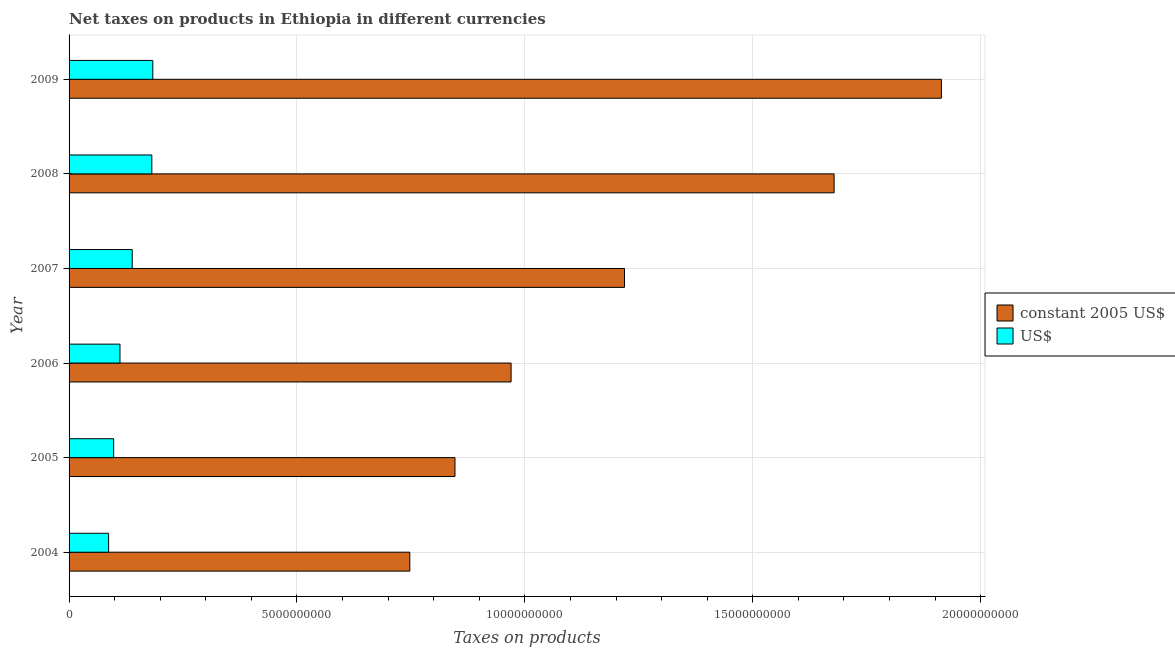How many different coloured bars are there?
Your answer should be compact. 2. How many groups of bars are there?
Your response must be concise. 6. How many bars are there on the 6th tick from the top?
Provide a succinct answer. 2. What is the label of the 2nd group of bars from the top?
Your answer should be compact. 2008. What is the net taxes in us$ in 2005?
Provide a short and direct response. 9.79e+08. Across all years, what is the maximum net taxes in us$?
Your answer should be compact. 1.84e+09. Across all years, what is the minimum net taxes in us$?
Your answer should be compact. 8.67e+08. What is the total net taxes in constant 2005 us$ in the graph?
Offer a very short reply. 7.38e+1. What is the difference between the net taxes in constant 2005 us$ in 2005 and that in 2007?
Keep it short and to the point. -3.72e+09. What is the difference between the net taxes in us$ in 2006 and the net taxes in constant 2005 us$ in 2007?
Ensure brevity in your answer.  -1.11e+1. What is the average net taxes in us$ per year?
Provide a succinct answer. 1.33e+09. In the year 2007, what is the difference between the net taxes in us$ and net taxes in constant 2005 us$?
Offer a very short reply. -1.08e+1. Is the difference between the net taxes in constant 2005 us$ in 2006 and 2007 greater than the difference between the net taxes in us$ in 2006 and 2007?
Make the answer very short. No. What is the difference between the highest and the second highest net taxes in us$?
Give a very brief answer. 2.12e+07. What is the difference between the highest and the lowest net taxes in us$?
Keep it short and to the point. 9.70e+08. In how many years, is the net taxes in constant 2005 us$ greater than the average net taxes in constant 2005 us$ taken over all years?
Provide a short and direct response. 2. What does the 1st bar from the top in 2009 represents?
Your response must be concise. US$. What does the 2nd bar from the bottom in 2006 represents?
Keep it short and to the point. US$. How many bars are there?
Provide a succinct answer. 12. What is the difference between two consecutive major ticks on the X-axis?
Keep it short and to the point. 5.00e+09. Are the values on the major ticks of X-axis written in scientific E-notation?
Your answer should be very brief. No. Does the graph contain grids?
Your response must be concise. Yes. What is the title of the graph?
Offer a terse response. Net taxes on products in Ethiopia in different currencies. What is the label or title of the X-axis?
Your answer should be very brief. Taxes on products. What is the label or title of the Y-axis?
Provide a succinct answer. Year. What is the Taxes on products in constant 2005 US$ in 2004?
Make the answer very short. 7.48e+09. What is the Taxes on products of US$ in 2004?
Give a very brief answer. 8.67e+08. What is the Taxes on products in constant 2005 US$ in 2005?
Your answer should be compact. 8.47e+09. What is the Taxes on products of US$ in 2005?
Your answer should be very brief. 9.79e+08. What is the Taxes on products of constant 2005 US$ in 2006?
Ensure brevity in your answer.  9.70e+09. What is the Taxes on products in US$ in 2006?
Your answer should be compact. 1.12e+09. What is the Taxes on products of constant 2005 US$ in 2007?
Provide a succinct answer. 1.22e+1. What is the Taxes on products in US$ in 2007?
Provide a short and direct response. 1.39e+09. What is the Taxes on products in constant 2005 US$ in 2008?
Your answer should be compact. 1.68e+1. What is the Taxes on products in US$ in 2008?
Make the answer very short. 1.82e+09. What is the Taxes on products of constant 2005 US$ in 2009?
Offer a terse response. 1.91e+1. What is the Taxes on products of US$ in 2009?
Provide a succinct answer. 1.84e+09. Across all years, what is the maximum Taxes on products in constant 2005 US$?
Provide a short and direct response. 1.91e+1. Across all years, what is the maximum Taxes on products of US$?
Keep it short and to the point. 1.84e+09. Across all years, what is the minimum Taxes on products in constant 2005 US$?
Offer a very short reply. 7.48e+09. Across all years, what is the minimum Taxes on products of US$?
Make the answer very short. 8.67e+08. What is the total Taxes on products in constant 2005 US$ in the graph?
Make the answer very short. 7.38e+1. What is the total Taxes on products of US$ in the graph?
Your answer should be compact. 8.00e+09. What is the difference between the Taxes on products of constant 2005 US$ in 2004 and that in 2005?
Give a very brief answer. -9.91e+08. What is the difference between the Taxes on products of US$ in 2004 and that in 2005?
Make the answer very short. -1.11e+08. What is the difference between the Taxes on products of constant 2005 US$ in 2004 and that in 2006?
Your response must be concise. -2.22e+09. What is the difference between the Taxes on products in US$ in 2004 and that in 2006?
Offer a very short reply. -2.50e+08. What is the difference between the Taxes on products in constant 2005 US$ in 2004 and that in 2007?
Make the answer very short. -4.71e+09. What is the difference between the Taxes on products in US$ in 2004 and that in 2007?
Keep it short and to the point. -5.18e+08. What is the difference between the Taxes on products in constant 2005 US$ in 2004 and that in 2008?
Offer a terse response. -9.31e+09. What is the difference between the Taxes on products of US$ in 2004 and that in 2008?
Make the answer very short. -9.48e+08. What is the difference between the Taxes on products of constant 2005 US$ in 2004 and that in 2009?
Keep it short and to the point. -1.17e+1. What is the difference between the Taxes on products of US$ in 2004 and that in 2009?
Your answer should be very brief. -9.70e+08. What is the difference between the Taxes on products of constant 2005 US$ in 2005 and that in 2006?
Keep it short and to the point. -1.23e+09. What is the difference between the Taxes on products in US$ in 2005 and that in 2006?
Provide a short and direct response. -1.39e+08. What is the difference between the Taxes on products of constant 2005 US$ in 2005 and that in 2007?
Offer a very short reply. -3.72e+09. What is the difference between the Taxes on products in US$ in 2005 and that in 2007?
Give a very brief answer. -4.07e+08. What is the difference between the Taxes on products in constant 2005 US$ in 2005 and that in 2008?
Keep it short and to the point. -8.32e+09. What is the difference between the Taxes on products of US$ in 2005 and that in 2008?
Ensure brevity in your answer.  -8.37e+08. What is the difference between the Taxes on products of constant 2005 US$ in 2005 and that in 2009?
Provide a short and direct response. -1.07e+1. What is the difference between the Taxes on products of US$ in 2005 and that in 2009?
Ensure brevity in your answer.  -8.58e+08. What is the difference between the Taxes on products in constant 2005 US$ in 2006 and that in 2007?
Provide a succinct answer. -2.49e+09. What is the difference between the Taxes on products in US$ in 2006 and that in 2007?
Provide a short and direct response. -2.69e+08. What is the difference between the Taxes on products in constant 2005 US$ in 2006 and that in 2008?
Keep it short and to the point. -7.09e+09. What is the difference between the Taxes on products of US$ in 2006 and that in 2008?
Give a very brief answer. -6.99e+08. What is the difference between the Taxes on products of constant 2005 US$ in 2006 and that in 2009?
Your response must be concise. -9.44e+09. What is the difference between the Taxes on products of US$ in 2006 and that in 2009?
Offer a terse response. -7.20e+08. What is the difference between the Taxes on products of constant 2005 US$ in 2007 and that in 2008?
Ensure brevity in your answer.  -4.60e+09. What is the difference between the Taxes on products of US$ in 2007 and that in 2008?
Keep it short and to the point. -4.30e+08. What is the difference between the Taxes on products of constant 2005 US$ in 2007 and that in 2009?
Ensure brevity in your answer.  -6.95e+09. What is the difference between the Taxes on products of US$ in 2007 and that in 2009?
Keep it short and to the point. -4.51e+08. What is the difference between the Taxes on products in constant 2005 US$ in 2008 and that in 2009?
Make the answer very short. -2.35e+09. What is the difference between the Taxes on products of US$ in 2008 and that in 2009?
Your answer should be compact. -2.12e+07. What is the difference between the Taxes on products of constant 2005 US$ in 2004 and the Taxes on products of US$ in 2005?
Provide a succinct answer. 6.50e+09. What is the difference between the Taxes on products in constant 2005 US$ in 2004 and the Taxes on products in US$ in 2006?
Provide a succinct answer. 6.36e+09. What is the difference between the Taxes on products of constant 2005 US$ in 2004 and the Taxes on products of US$ in 2007?
Offer a very short reply. 6.09e+09. What is the difference between the Taxes on products of constant 2005 US$ in 2004 and the Taxes on products of US$ in 2008?
Offer a very short reply. 5.66e+09. What is the difference between the Taxes on products in constant 2005 US$ in 2004 and the Taxes on products in US$ in 2009?
Keep it short and to the point. 5.64e+09. What is the difference between the Taxes on products of constant 2005 US$ in 2005 and the Taxes on products of US$ in 2006?
Offer a terse response. 7.35e+09. What is the difference between the Taxes on products of constant 2005 US$ in 2005 and the Taxes on products of US$ in 2007?
Make the answer very short. 7.08e+09. What is the difference between the Taxes on products in constant 2005 US$ in 2005 and the Taxes on products in US$ in 2008?
Give a very brief answer. 6.65e+09. What is the difference between the Taxes on products of constant 2005 US$ in 2005 and the Taxes on products of US$ in 2009?
Provide a succinct answer. 6.63e+09. What is the difference between the Taxes on products in constant 2005 US$ in 2006 and the Taxes on products in US$ in 2007?
Provide a succinct answer. 8.31e+09. What is the difference between the Taxes on products of constant 2005 US$ in 2006 and the Taxes on products of US$ in 2008?
Give a very brief answer. 7.88e+09. What is the difference between the Taxes on products of constant 2005 US$ in 2006 and the Taxes on products of US$ in 2009?
Ensure brevity in your answer.  7.86e+09. What is the difference between the Taxes on products of constant 2005 US$ in 2007 and the Taxes on products of US$ in 2008?
Offer a very short reply. 1.04e+1. What is the difference between the Taxes on products of constant 2005 US$ in 2007 and the Taxes on products of US$ in 2009?
Make the answer very short. 1.03e+1. What is the difference between the Taxes on products in constant 2005 US$ in 2008 and the Taxes on products in US$ in 2009?
Give a very brief answer. 1.49e+1. What is the average Taxes on products of constant 2005 US$ per year?
Keep it short and to the point. 1.23e+1. What is the average Taxes on products in US$ per year?
Keep it short and to the point. 1.33e+09. In the year 2004, what is the difference between the Taxes on products of constant 2005 US$ and Taxes on products of US$?
Make the answer very short. 6.61e+09. In the year 2005, what is the difference between the Taxes on products in constant 2005 US$ and Taxes on products in US$?
Make the answer very short. 7.49e+09. In the year 2006, what is the difference between the Taxes on products in constant 2005 US$ and Taxes on products in US$?
Your answer should be compact. 8.58e+09. In the year 2007, what is the difference between the Taxes on products in constant 2005 US$ and Taxes on products in US$?
Offer a terse response. 1.08e+1. In the year 2008, what is the difference between the Taxes on products of constant 2005 US$ and Taxes on products of US$?
Your response must be concise. 1.50e+1. In the year 2009, what is the difference between the Taxes on products in constant 2005 US$ and Taxes on products in US$?
Make the answer very short. 1.73e+1. What is the ratio of the Taxes on products of constant 2005 US$ in 2004 to that in 2005?
Your answer should be very brief. 0.88. What is the ratio of the Taxes on products of US$ in 2004 to that in 2005?
Your response must be concise. 0.89. What is the ratio of the Taxes on products in constant 2005 US$ in 2004 to that in 2006?
Your response must be concise. 0.77. What is the ratio of the Taxes on products in US$ in 2004 to that in 2006?
Offer a terse response. 0.78. What is the ratio of the Taxes on products in constant 2005 US$ in 2004 to that in 2007?
Offer a very short reply. 0.61. What is the ratio of the Taxes on products in US$ in 2004 to that in 2007?
Your answer should be very brief. 0.63. What is the ratio of the Taxes on products of constant 2005 US$ in 2004 to that in 2008?
Your response must be concise. 0.45. What is the ratio of the Taxes on products of US$ in 2004 to that in 2008?
Ensure brevity in your answer.  0.48. What is the ratio of the Taxes on products of constant 2005 US$ in 2004 to that in 2009?
Make the answer very short. 0.39. What is the ratio of the Taxes on products of US$ in 2004 to that in 2009?
Provide a short and direct response. 0.47. What is the ratio of the Taxes on products of constant 2005 US$ in 2005 to that in 2006?
Make the answer very short. 0.87. What is the ratio of the Taxes on products of US$ in 2005 to that in 2006?
Your answer should be compact. 0.88. What is the ratio of the Taxes on products in constant 2005 US$ in 2005 to that in 2007?
Offer a terse response. 0.69. What is the ratio of the Taxes on products of US$ in 2005 to that in 2007?
Your answer should be very brief. 0.71. What is the ratio of the Taxes on products in constant 2005 US$ in 2005 to that in 2008?
Your answer should be compact. 0.5. What is the ratio of the Taxes on products of US$ in 2005 to that in 2008?
Offer a very short reply. 0.54. What is the ratio of the Taxes on products in constant 2005 US$ in 2005 to that in 2009?
Provide a short and direct response. 0.44. What is the ratio of the Taxes on products of US$ in 2005 to that in 2009?
Ensure brevity in your answer.  0.53. What is the ratio of the Taxes on products in constant 2005 US$ in 2006 to that in 2007?
Ensure brevity in your answer.  0.8. What is the ratio of the Taxes on products in US$ in 2006 to that in 2007?
Make the answer very short. 0.81. What is the ratio of the Taxes on products of constant 2005 US$ in 2006 to that in 2008?
Provide a short and direct response. 0.58. What is the ratio of the Taxes on products of US$ in 2006 to that in 2008?
Ensure brevity in your answer.  0.62. What is the ratio of the Taxes on products in constant 2005 US$ in 2006 to that in 2009?
Make the answer very short. 0.51. What is the ratio of the Taxes on products in US$ in 2006 to that in 2009?
Offer a terse response. 0.61. What is the ratio of the Taxes on products in constant 2005 US$ in 2007 to that in 2008?
Your response must be concise. 0.73. What is the ratio of the Taxes on products of US$ in 2007 to that in 2008?
Keep it short and to the point. 0.76. What is the ratio of the Taxes on products in constant 2005 US$ in 2007 to that in 2009?
Your answer should be compact. 0.64. What is the ratio of the Taxes on products of US$ in 2007 to that in 2009?
Your response must be concise. 0.75. What is the ratio of the Taxes on products in constant 2005 US$ in 2008 to that in 2009?
Your answer should be compact. 0.88. What is the ratio of the Taxes on products in US$ in 2008 to that in 2009?
Your answer should be compact. 0.99. What is the difference between the highest and the second highest Taxes on products of constant 2005 US$?
Keep it short and to the point. 2.35e+09. What is the difference between the highest and the second highest Taxes on products in US$?
Give a very brief answer. 2.12e+07. What is the difference between the highest and the lowest Taxes on products in constant 2005 US$?
Your answer should be compact. 1.17e+1. What is the difference between the highest and the lowest Taxes on products of US$?
Ensure brevity in your answer.  9.70e+08. 